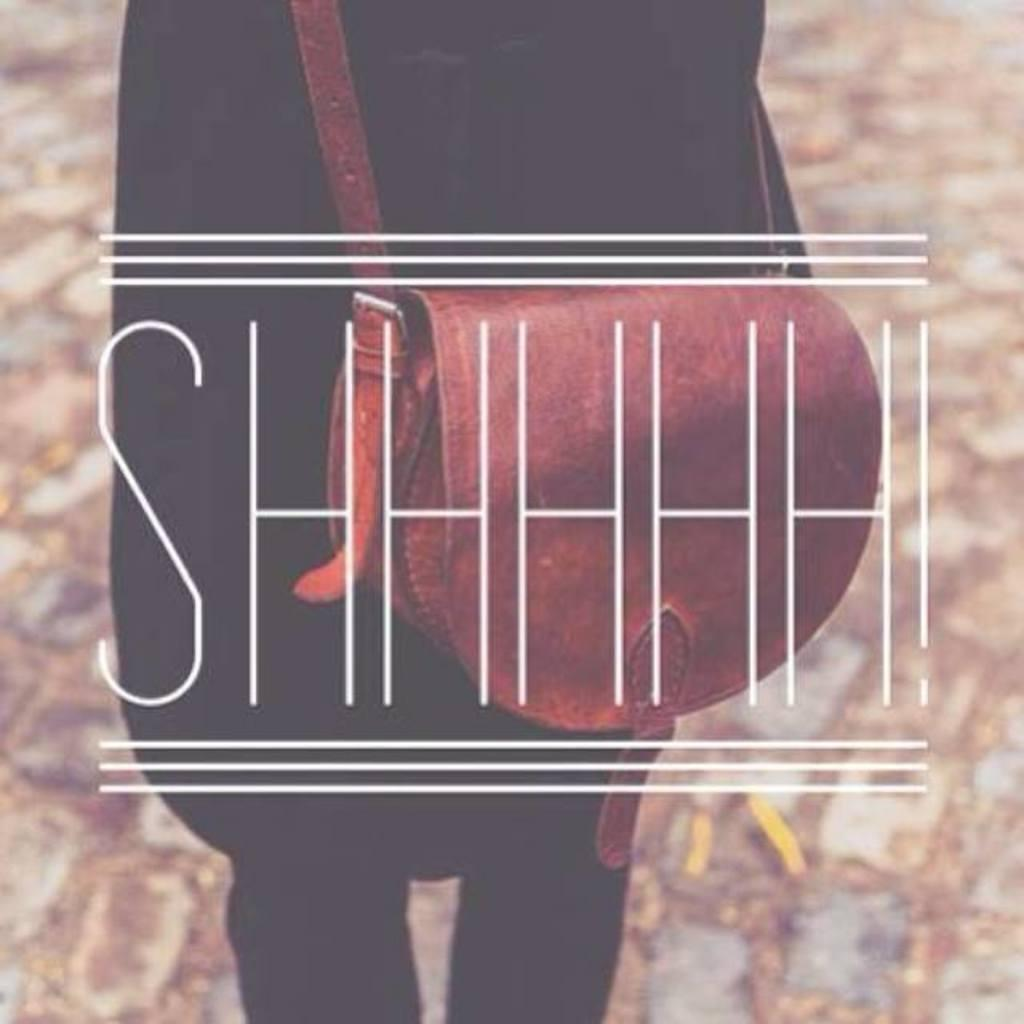What is the main subject of the image? There is a person in the image. What is the person wearing? The person is wearing a bag. What can be seen in the background of the image? There is a wall in the image. Are there any words or letters in the image? Yes, there is text in the image. What type of error can be seen in the text of the image? There is no error present in the text of the image. How much zinc is visible in the image? There is no zinc present in the image. 